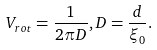<formula> <loc_0><loc_0><loc_500><loc_500>V _ { r o t } = \frac { 1 } { 2 \pi D } , D = \frac { d } { \xi _ { 0 } } .</formula> 